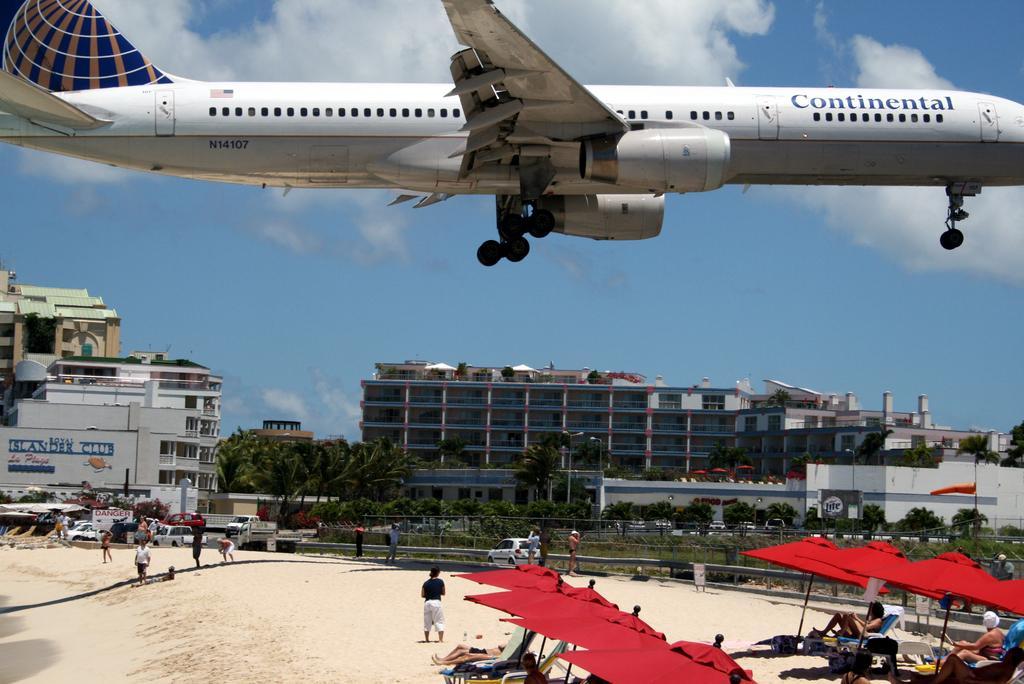Could you give a brief overview of what you see in this image? In this picture there are buildings and trees and there are vehicles on the road. In the foreground there are group of people sitting under the umbrellas and there are group of people standing on the sand. At the top there is an aircraft in the air and there is sky and there are clouds. At the bottom there is sand. 